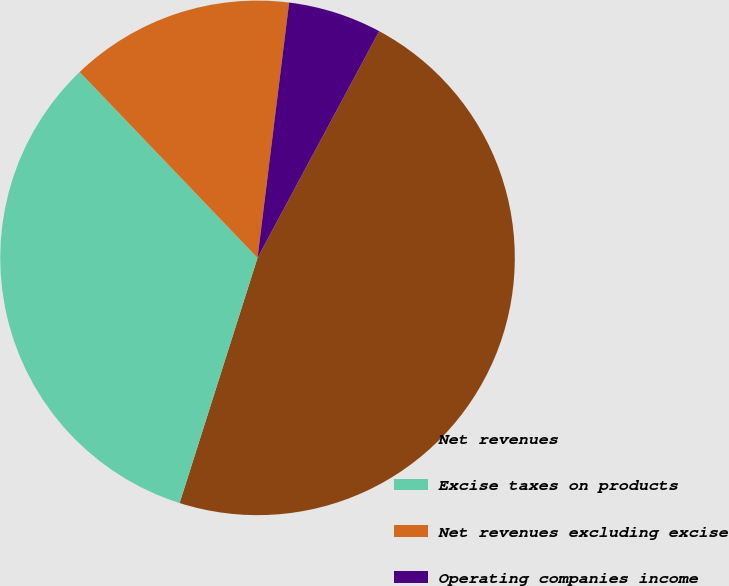<chart> <loc_0><loc_0><loc_500><loc_500><pie_chart><fcel>Net revenues<fcel>Excise taxes on products<fcel>Net revenues excluding excise<fcel>Operating companies income<nl><fcel>47.06%<fcel>32.95%<fcel>14.11%<fcel>5.88%<nl></chart> 